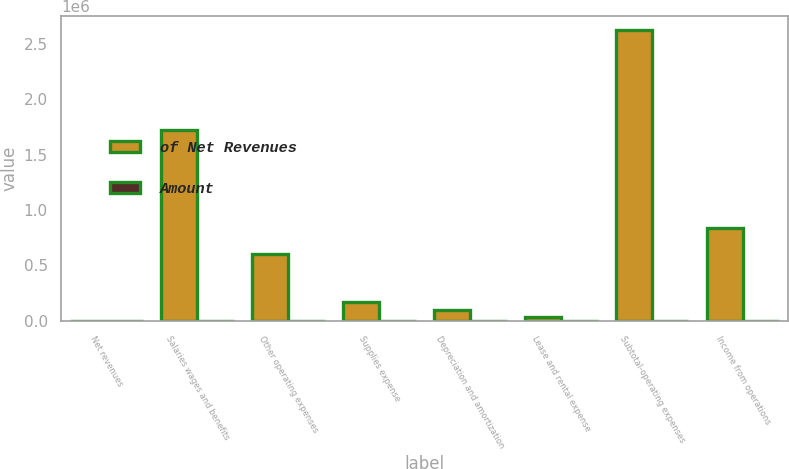<chart> <loc_0><loc_0><loc_500><loc_500><stacked_bar_chart><ecel><fcel>Net revenues<fcel>Salaries wages and benefits<fcel>Other operating expenses<fcel>Supplies expense<fcel>Depreciation and amortization<fcel>Lease and rental expense<fcel>Subtotal-operating expenses<fcel>Income from operations<nl><fcel>of Net Revenues<fcel>100<fcel>1.71775e+06<fcel>603700<fcel>169552<fcel>94049<fcel>34569<fcel>2.61962e+06<fcel>840520<nl><fcel>Amount<fcel>100<fcel>49.6<fcel>17.4<fcel>4.9<fcel>2.7<fcel>1<fcel>75.7<fcel>24.3<nl></chart> 